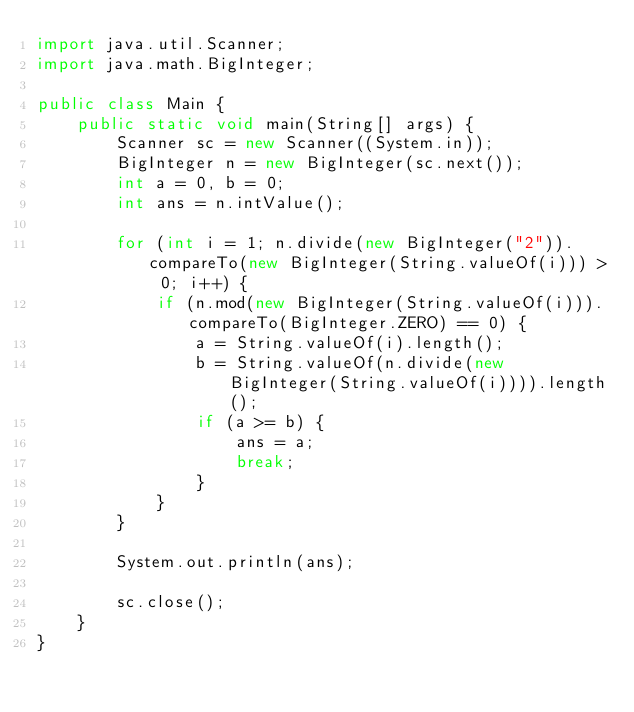<code> <loc_0><loc_0><loc_500><loc_500><_Java_>import java.util.Scanner;
import java.math.BigInteger;

public class Main {
	public static void main(String[] args) {
		Scanner sc = new Scanner((System.in));
		BigInteger n = new BigInteger(sc.next());
		int a = 0, b = 0;
		int ans = n.intValue();

		for (int i = 1; n.divide(new BigInteger("2")).compareTo(new BigInteger(String.valueOf(i))) > 0; i++) {
			if (n.mod(new BigInteger(String.valueOf(i))).compareTo(BigInteger.ZERO) == 0) {
				a = String.valueOf(i).length();
				b = String.valueOf(n.divide(new BigInteger(String.valueOf(i)))).length();
				if (a >= b) {
					ans = a;
					break;
				}
			}
		}

		System.out.println(ans);

		sc.close();
	}
}
</code> 